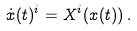Convert formula to latex. <formula><loc_0><loc_0><loc_500><loc_500>\dot { x } ( t ) ^ { i } = X ^ { i } ( x ( t ) ) \, .</formula> 